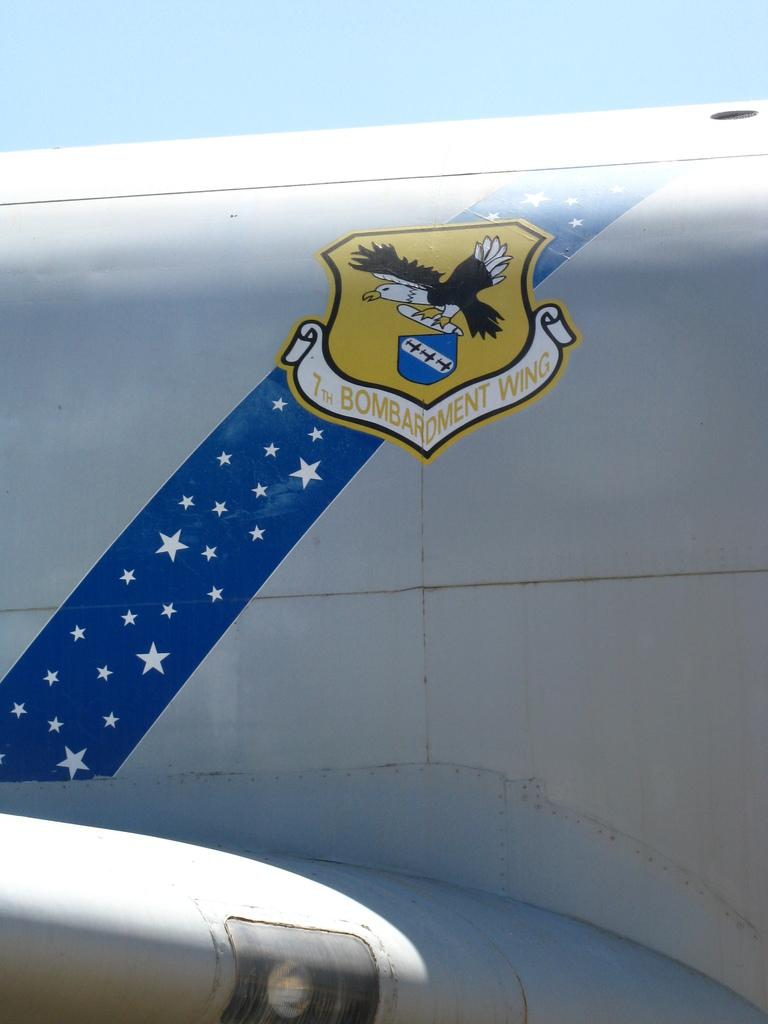<image>
Relay a brief, clear account of the picture shown. An up close photo of an American bomber for the 7th bombardment wing. 